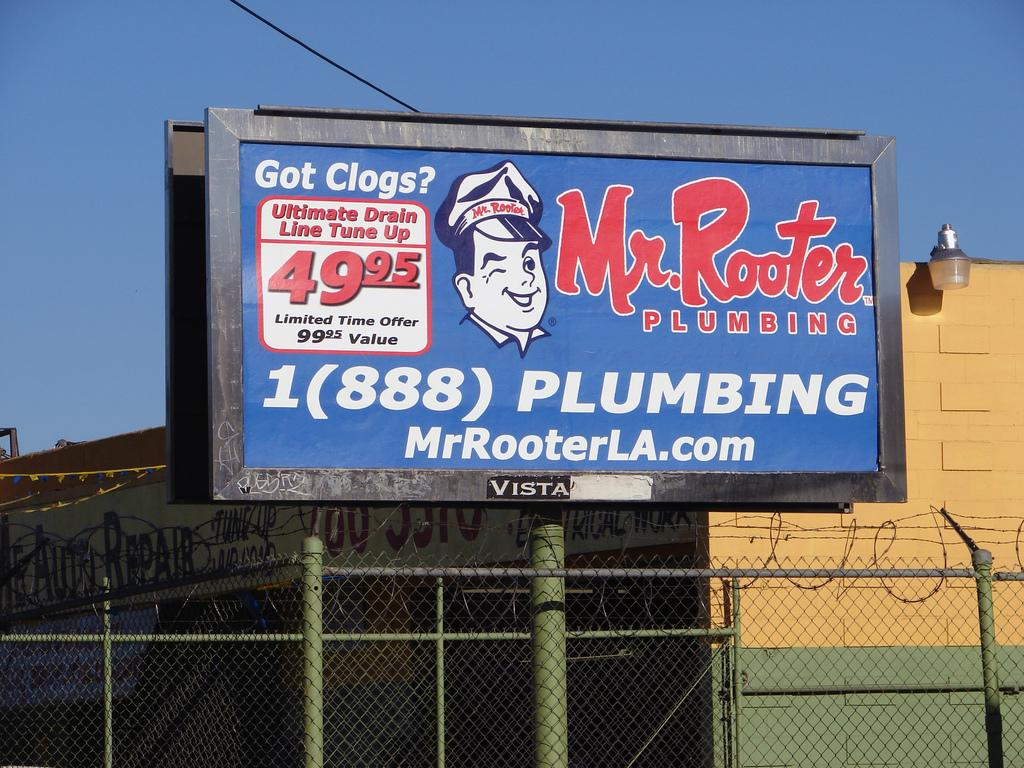<image>
Offer a succinct explanation of the picture presented. A billboard of an advertisement for Mr. Rooter Plumbing with the phone number and website. 